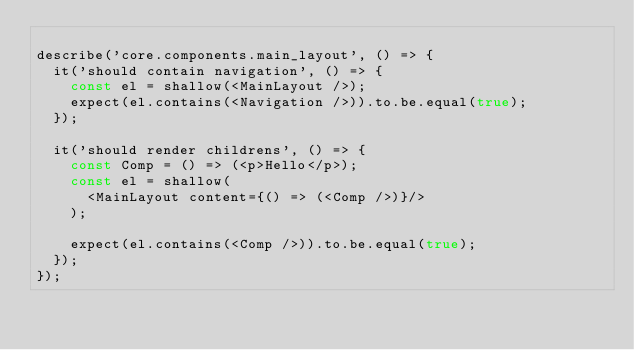Convert code to text. <code><loc_0><loc_0><loc_500><loc_500><_JavaScript_>
describe('core.components.main_layout', () => {
  it('should contain navigation', () => {
    const el = shallow(<MainLayout />);
    expect(el.contains(<Navigation />)).to.be.equal(true);
  });

  it('should render childrens', () => {
    const Comp = () => (<p>Hello</p>);
    const el = shallow(
      <MainLayout content={() => (<Comp />)}/>
    );

    expect(el.contains(<Comp />)).to.be.equal(true);
  });
});
</code> 